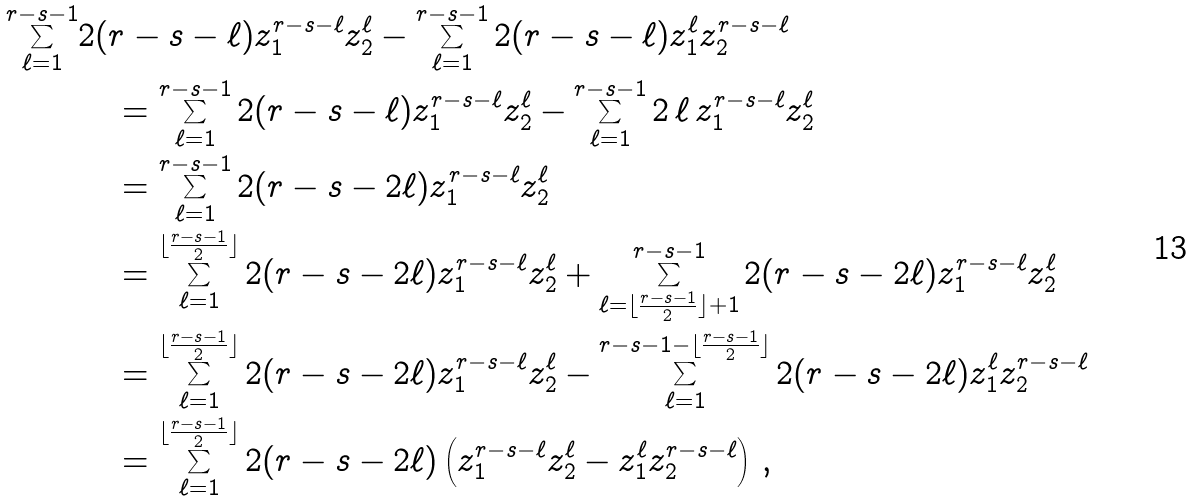<formula> <loc_0><loc_0><loc_500><loc_500>\sum _ { \ell = 1 } ^ { r - s - 1 } & 2 ( r - s - \ell ) z _ { 1 } ^ { r - s - \ell } z _ { 2 } ^ { \ell } - \sum _ { \ell = 1 } ^ { r - s - 1 } 2 ( r - s - \ell ) z _ { 1 } ^ { \ell } z _ { 2 } ^ { r - s - \ell } \\ & \quad = \sum _ { \ell = 1 } ^ { r - s - 1 } 2 ( r - s - \ell ) z _ { 1 } ^ { r - s - \ell } z _ { 2 } ^ { \ell } - \sum _ { \ell = 1 } ^ { r - s - 1 } 2 \, \ell \, z _ { 1 } ^ { r - s - \ell } z _ { 2 } ^ { \ell } \\ & \quad = \sum _ { \ell = 1 } ^ { r - s - 1 } 2 ( r - s - 2 \ell ) z _ { 1 } ^ { r - s - \ell } z _ { 2 } ^ { \ell } \\ & \quad = \sum _ { \ell = 1 } ^ { \lfloor \frac { r - s - 1 } { 2 } \rfloor } 2 ( r - s - 2 \ell ) z _ { 1 } ^ { r - s - \ell } z _ { 2 } ^ { \ell } + \sum _ { \ell = \lfloor \frac { r - s - 1 } { 2 } \rfloor + 1 } ^ { r - s - 1 } 2 ( r - s - 2 \ell ) z _ { 1 } ^ { r - s - \ell } z _ { 2 } ^ { \ell } \\ & \quad = \sum _ { \ell = 1 } ^ { \lfloor \frac { r - s - 1 } { 2 } \rfloor } 2 ( r - s - 2 \ell ) z _ { 1 } ^ { r - s - \ell } z _ { 2 } ^ { \ell } - \sum ^ { r - s - 1 - \lfloor \frac { r - s - 1 } { 2 } \rfloor } _ { \ell = 1 } 2 ( r - s - 2 \ell ) z _ { 1 } ^ { \ell } z _ { 2 } ^ { r - s - \ell } \\ & \quad = \sum _ { \ell = 1 } ^ { \lfloor \frac { r - s - 1 } { 2 } \rfloor } 2 ( r - s - 2 \ell ) \left ( z _ { 1 } ^ { r - s - \ell } z _ { 2 } ^ { \ell } - z _ { 1 } ^ { \ell } z _ { 2 } ^ { r - s - \ell } \right ) \, ,</formula> 